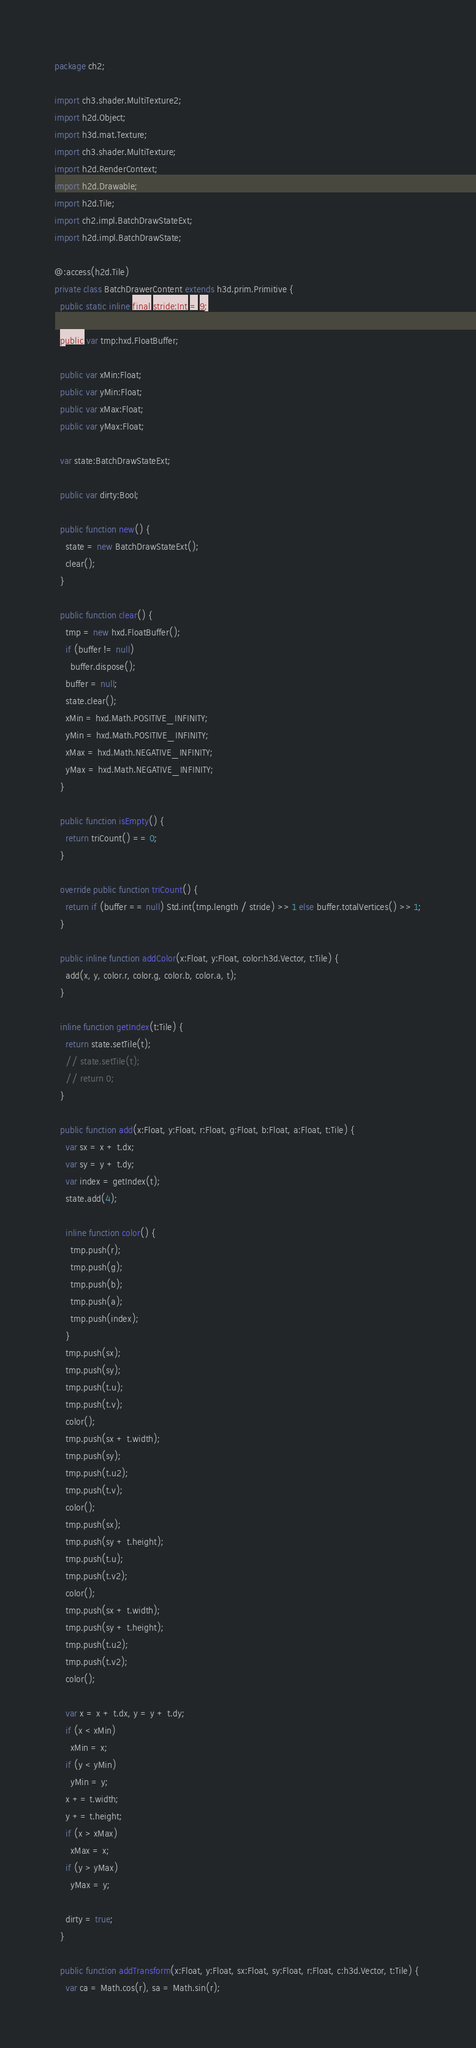Convert code to text. <code><loc_0><loc_0><loc_500><loc_500><_Haxe_>package ch2;

import ch3.shader.MultiTexture2;
import h2d.Object;
import h3d.mat.Texture;
import ch3.shader.MultiTexture;
import h2d.RenderContext;
import h2d.Drawable;
import h2d.Tile;
import ch2.impl.BatchDrawStateExt;
import h2d.impl.BatchDrawState;

@:access(h2d.Tile)
private class BatchDrawerContent extends h3d.prim.Primitive {
  public static inline final stride:Int = 9;

  public var tmp:hxd.FloatBuffer;

  public var xMin:Float;
  public var yMin:Float;
  public var xMax:Float;
  public var yMax:Float;
  
  var state:BatchDrawStateExt;

  public var dirty:Bool;

  public function new() {
    state = new BatchDrawStateExt();
    clear();
  }

  public function clear() {
    tmp = new hxd.FloatBuffer();
    if (buffer != null)
      buffer.dispose();
    buffer = null;
    state.clear();
    xMin = hxd.Math.POSITIVE_INFINITY;
    yMin = hxd.Math.POSITIVE_INFINITY;
    xMax = hxd.Math.NEGATIVE_INFINITY;
    yMax = hxd.Math.NEGATIVE_INFINITY;
  }

  public function isEmpty() {
    return triCount() == 0;
  }

  override public function triCount() {
    return if (buffer == null) Std.int(tmp.length / stride) >> 1 else buffer.totalVertices() >> 1;
  }

  public inline function addColor(x:Float, y:Float, color:h3d.Vector, t:Tile) {
    add(x, y, color.r, color.g, color.b, color.a, t);
  }

  inline function getIndex(t:Tile) {
    return state.setTile(t);
    // state.setTile(t);
    // return 0;
  }

  public function add(x:Float, y:Float, r:Float, g:Float, b:Float, a:Float, t:Tile) {
    var sx = x + t.dx;
    var sy = y + t.dy;
    var index = getIndex(t);
    state.add(4);
    
    inline function color() {
      tmp.push(r);
      tmp.push(g);
      tmp.push(b);
      tmp.push(a);
      tmp.push(index);
    }
    tmp.push(sx);
    tmp.push(sy);
    tmp.push(t.u);
    tmp.push(t.v);
    color();
    tmp.push(sx + t.width);
    tmp.push(sy);
    tmp.push(t.u2);
    tmp.push(t.v);
    color();
    tmp.push(sx);
    tmp.push(sy + t.height);
    tmp.push(t.u);
    tmp.push(t.v2);
    color();
    tmp.push(sx + t.width);
    tmp.push(sy + t.height);
    tmp.push(t.u2);
    tmp.push(t.v2);
    color();

    var x = x + t.dx, y = y + t.dy;
    if (x < xMin)
      xMin = x;
    if (y < yMin)
      yMin = y;
    x += t.width;
    y += t.height;
    if (x > xMax)
      xMax = x;
    if (y > yMax)
      yMax = y;

    dirty = true;
  }

  public function addTransform(x:Float, y:Float, sx:Float, sy:Float, r:Float, c:h3d.Vector, t:Tile) {
    var ca = Math.cos(r), sa = Math.sin(r);</code> 